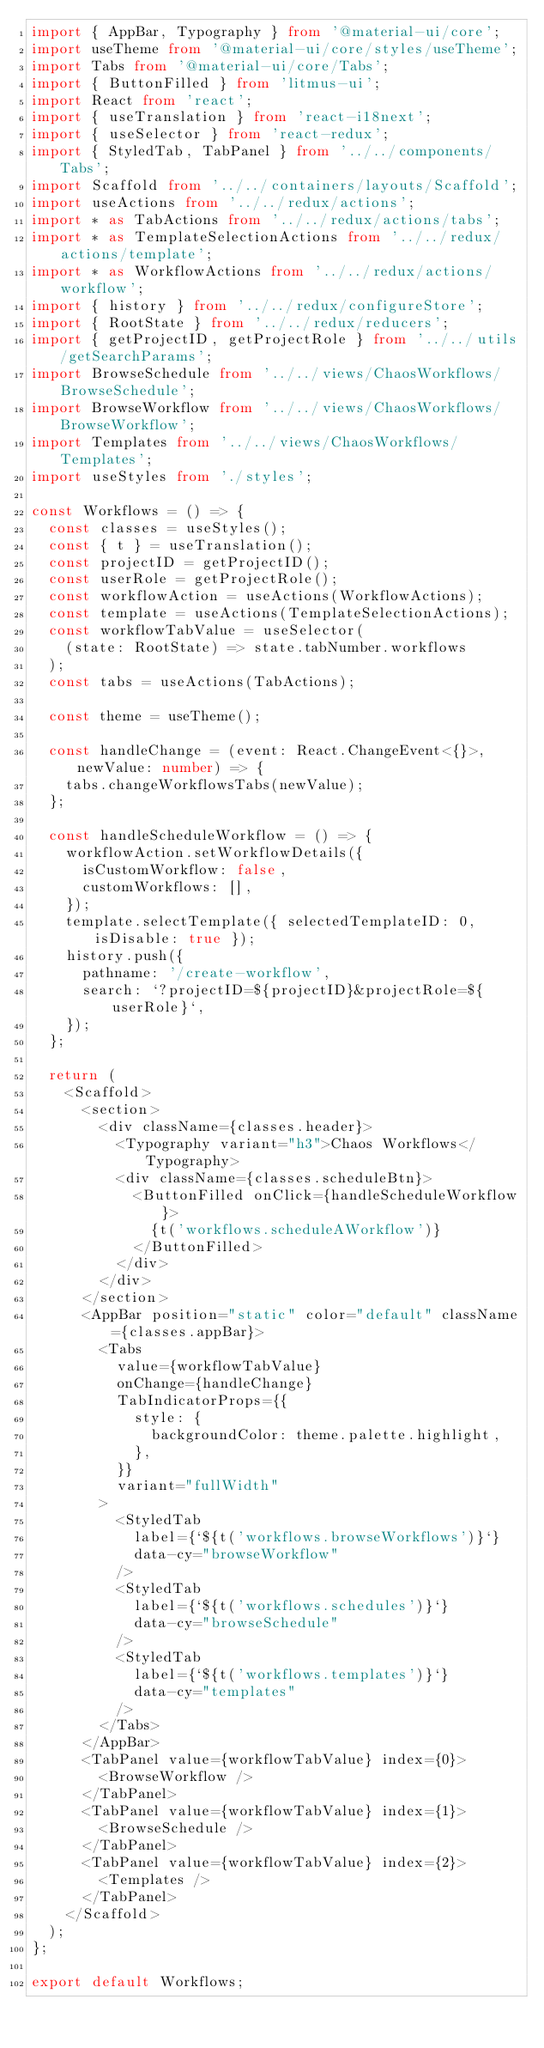<code> <loc_0><loc_0><loc_500><loc_500><_TypeScript_>import { AppBar, Typography } from '@material-ui/core';
import useTheme from '@material-ui/core/styles/useTheme';
import Tabs from '@material-ui/core/Tabs';
import { ButtonFilled } from 'litmus-ui';
import React from 'react';
import { useTranslation } from 'react-i18next';
import { useSelector } from 'react-redux';
import { StyledTab, TabPanel } from '../../components/Tabs';
import Scaffold from '../../containers/layouts/Scaffold';
import useActions from '../../redux/actions';
import * as TabActions from '../../redux/actions/tabs';
import * as TemplateSelectionActions from '../../redux/actions/template';
import * as WorkflowActions from '../../redux/actions/workflow';
import { history } from '../../redux/configureStore';
import { RootState } from '../../redux/reducers';
import { getProjectID, getProjectRole } from '../../utils/getSearchParams';
import BrowseSchedule from '../../views/ChaosWorkflows/BrowseSchedule';
import BrowseWorkflow from '../../views/ChaosWorkflows/BrowseWorkflow';
import Templates from '../../views/ChaosWorkflows/Templates';
import useStyles from './styles';

const Workflows = () => {
  const classes = useStyles();
  const { t } = useTranslation();
  const projectID = getProjectID();
  const userRole = getProjectRole();
  const workflowAction = useActions(WorkflowActions);
  const template = useActions(TemplateSelectionActions);
  const workflowTabValue = useSelector(
    (state: RootState) => state.tabNumber.workflows
  );
  const tabs = useActions(TabActions);

  const theme = useTheme();

  const handleChange = (event: React.ChangeEvent<{}>, newValue: number) => {
    tabs.changeWorkflowsTabs(newValue);
  };

  const handleScheduleWorkflow = () => {
    workflowAction.setWorkflowDetails({
      isCustomWorkflow: false,
      customWorkflows: [],
    });
    template.selectTemplate({ selectedTemplateID: 0, isDisable: true });
    history.push({
      pathname: '/create-workflow',
      search: `?projectID=${projectID}&projectRole=${userRole}`,
    });
  };

  return (
    <Scaffold>
      <section>
        <div className={classes.header}>
          <Typography variant="h3">Chaos Workflows</Typography>
          <div className={classes.scheduleBtn}>
            <ButtonFilled onClick={handleScheduleWorkflow}>
              {t('workflows.scheduleAWorkflow')}
            </ButtonFilled>
          </div>
        </div>
      </section>
      <AppBar position="static" color="default" className={classes.appBar}>
        <Tabs
          value={workflowTabValue}
          onChange={handleChange}
          TabIndicatorProps={{
            style: {
              backgroundColor: theme.palette.highlight,
            },
          }}
          variant="fullWidth"
        >
          <StyledTab
            label={`${t('workflows.browseWorkflows')}`}
            data-cy="browseWorkflow"
          />
          <StyledTab
            label={`${t('workflows.schedules')}`}
            data-cy="browseSchedule"
          />
          <StyledTab
            label={`${t('workflows.templates')}`}
            data-cy="templates"
          />
        </Tabs>
      </AppBar>
      <TabPanel value={workflowTabValue} index={0}>
        <BrowseWorkflow />
      </TabPanel>
      <TabPanel value={workflowTabValue} index={1}>
        <BrowseSchedule />
      </TabPanel>
      <TabPanel value={workflowTabValue} index={2}>
        <Templates />
      </TabPanel>
    </Scaffold>
  );
};

export default Workflows;
</code> 